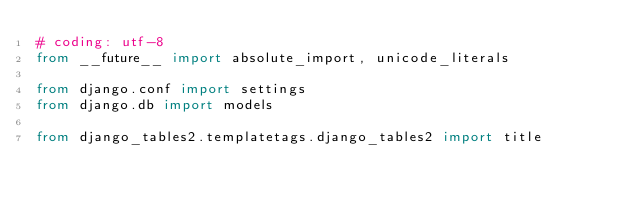<code> <loc_0><loc_0><loc_500><loc_500><_Python_># coding: utf-8
from __future__ import absolute_import, unicode_literals

from django.conf import settings
from django.db import models

from django_tables2.templatetags.django_tables2 import title
</code> 